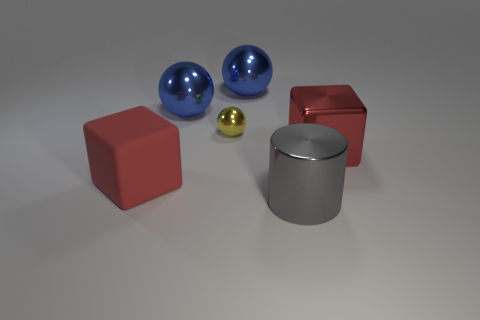How many other objects are there of the same material as the big gray cylinder?
Your answer should be compact. 4. What material is the small object?
Give a very brief answer. Metal. What size is the yellow shiny sphere that is behind the big shiny cylinder?
Your answer should be very brief. Small. There is a red cube right of the big red matte cube; how many large red blocks are left of it?
Keep it short and to the point. 1. Is the shape of the big red thing that is right of the gray metallic object the same as the big red object to the left of the small yellow sphere?
Make the answer very short. Yes. What number of big objects are both right of the yellow object and in front of the yellow metallic object?
Give a very brief answer. 2. Is there another large block of the same color as the big metallic block?
Make the answer very short. Yes. What shape is the red matte object that is the same size as the gray metallic cylinder?
Give a very brief answer. Cube. Are there any gray metal things to the right of the big gray cylinder?
Make the answer very short. No. Do the red block on the right side of the gray shiny thing and the small ball behind the large gray thing have the same material?
Make the answer very short. Yes. 